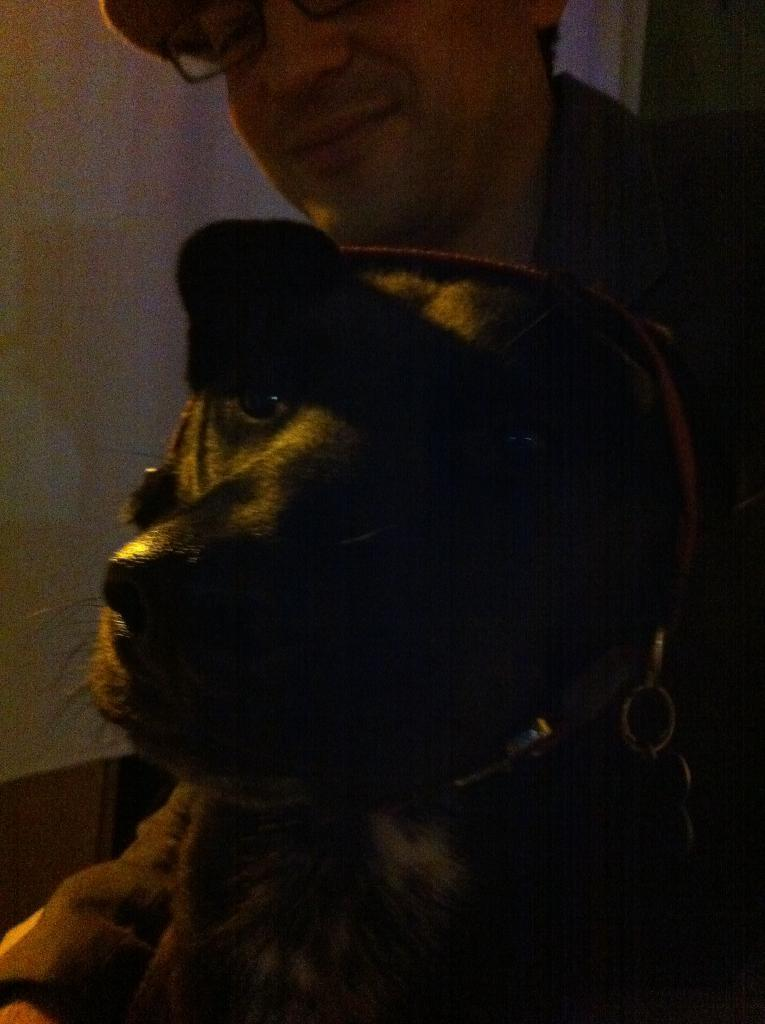What type of animal is in the image? There is a dog in the image. Who or what else is in the image? There is a person in the image. What can be seen in the background of the image? There is a wall and other objects in the background of the image. What type of minister is depicted in the image? There is no minister present in the image; it features a dog and a person. What error can be seen in the image? There is no error present in the image; it appears to be a clear and accurate representation of the dog and person. 